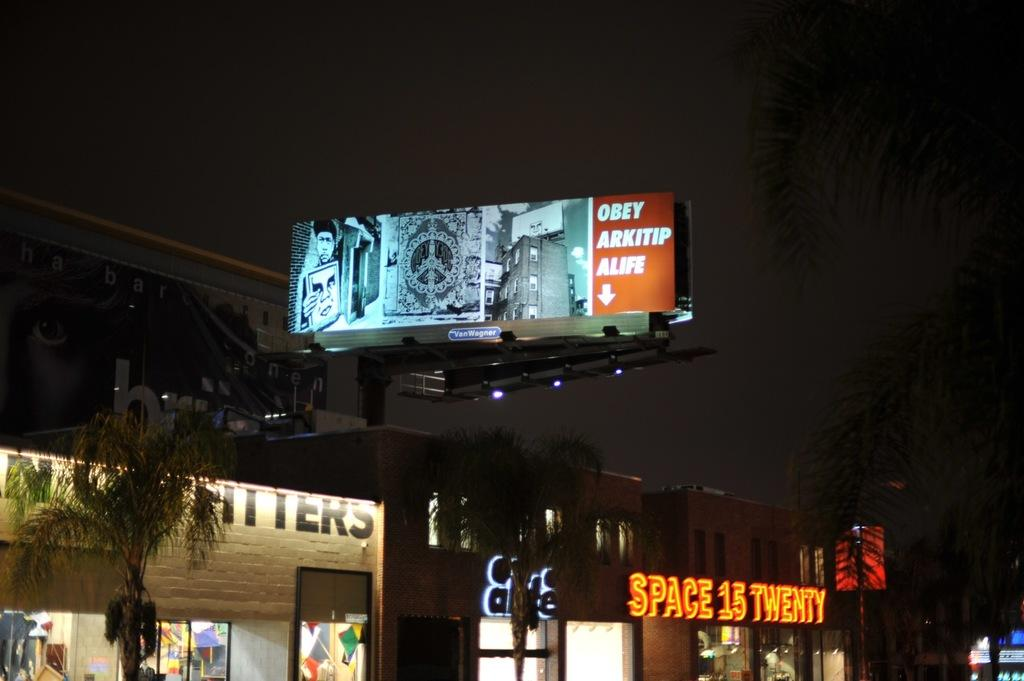<image>
Summarize the visual content of the image. Billboard that says Obey Arkitip Alife with a arrow pointing down below. 